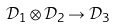<formula> <loc_0><loc_0><loc_500><loc_500>\mathcal { D } _ { 1 } \otimes \mathcal { D } _ { 2 } \rightarrow \mathcal { D } _ { 3 }</formula> 